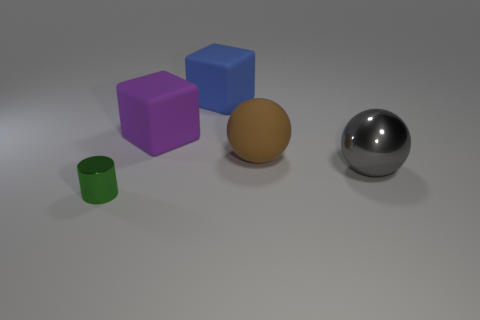Is the number of large gray metal spheres left of the large brown thing the same as the number of large brown metal balls?
Ensure brevity in your answer.  Yes. How many other things are there of the same shape as the big brown thing?
Offer a terse response. 1. There is a tiny green object; what number of metal things are on the right side of it?
Your answer should be very brief. 1. There is a thing that is left of the large blue thing and behind the tiny object; what is its size?
Give a very brief answer. Large. Are there any big metal objects?
Your answer should be very brief. Yes. What number of other things are there of the same size as the gray shiny ball?
Your response must be concise. 3. There is a metallic object that is on the right side of the small green metal cylinder; is it the same color as the shiny thing on the left side of the brown matte object?
Make the answer very short. No. There is a rubber thing that is the same shape as the big gray metallic object; what is its size?
Give a very brief answer. Large. Do the large object that is in front of the big brown object and the object that is in front of the metallic ball have the same material?
Make the answer very short. Yes. What number of rubber things are blue things or large blocks?
Keep it short and to the point. 2. 